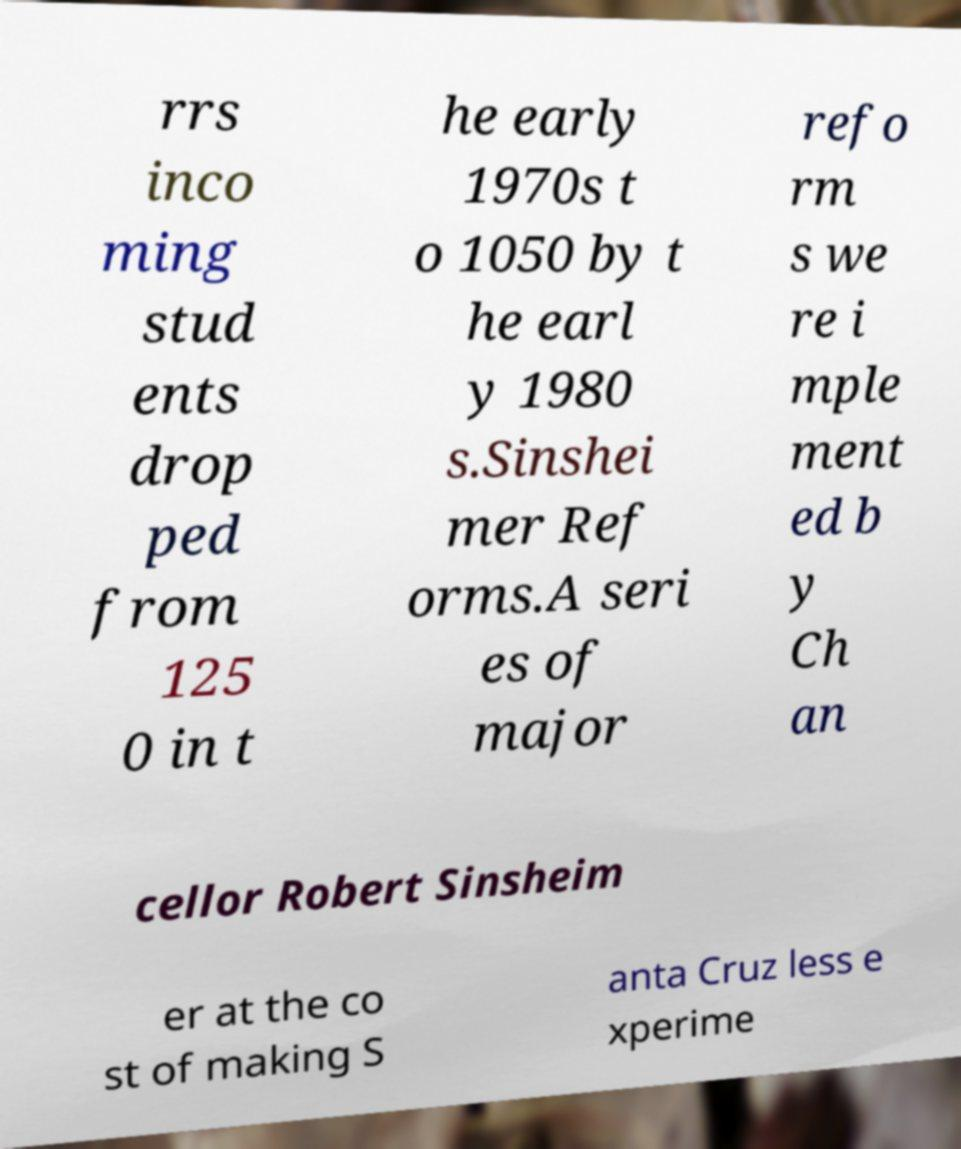Could you extract and type out the text from this image? rrs inco ming stud ents drop ped from 125 0 in t he early 1970s t o 1050 by t he earl y 1980 s.Sinshei mer Ref orms.A seri es of major refo rm s we re i mple ment ed b y Ch an cellor Robert Sinsheim er at the co st of making S anta Cruz less e xperime 